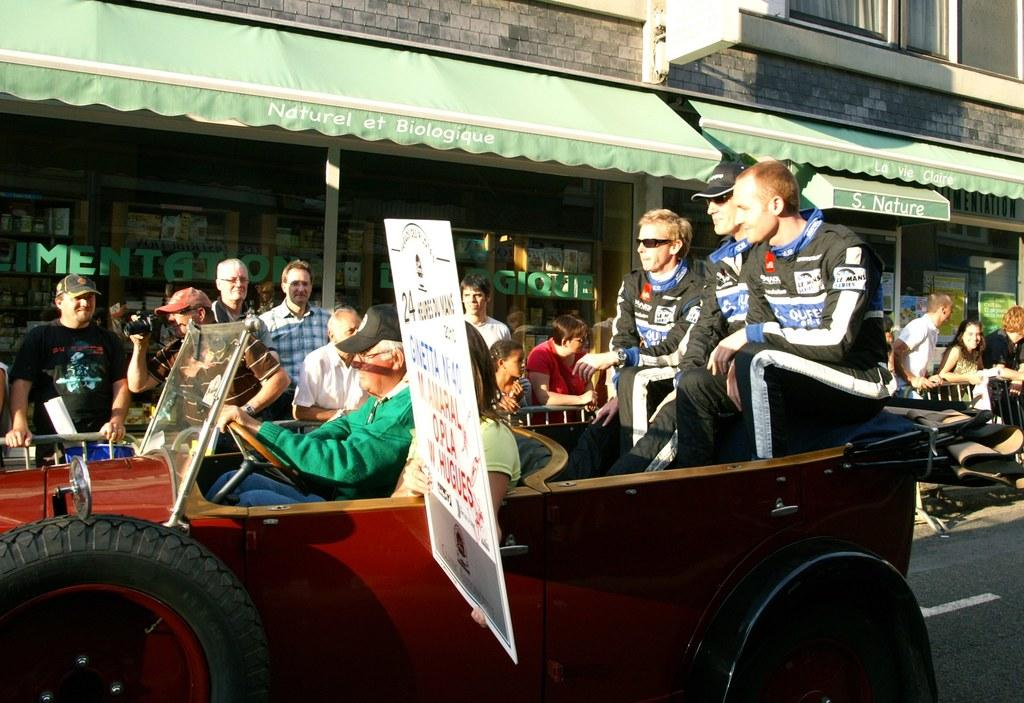What is on the road in the image? There is a vehicle on the road in the image. Who or what else can be seen in the image? There is a group of people in the image. What is the board used for in the image? The purpose of the board in the image is not specified, but it is present. What can be seen in the distance in the image? There is a building and other objects visible in the background of the image. Can you see any deer in the image? There are no deer present in the image. What type of bread is being used by the group of people in the image? There is no bread visible in the image. 